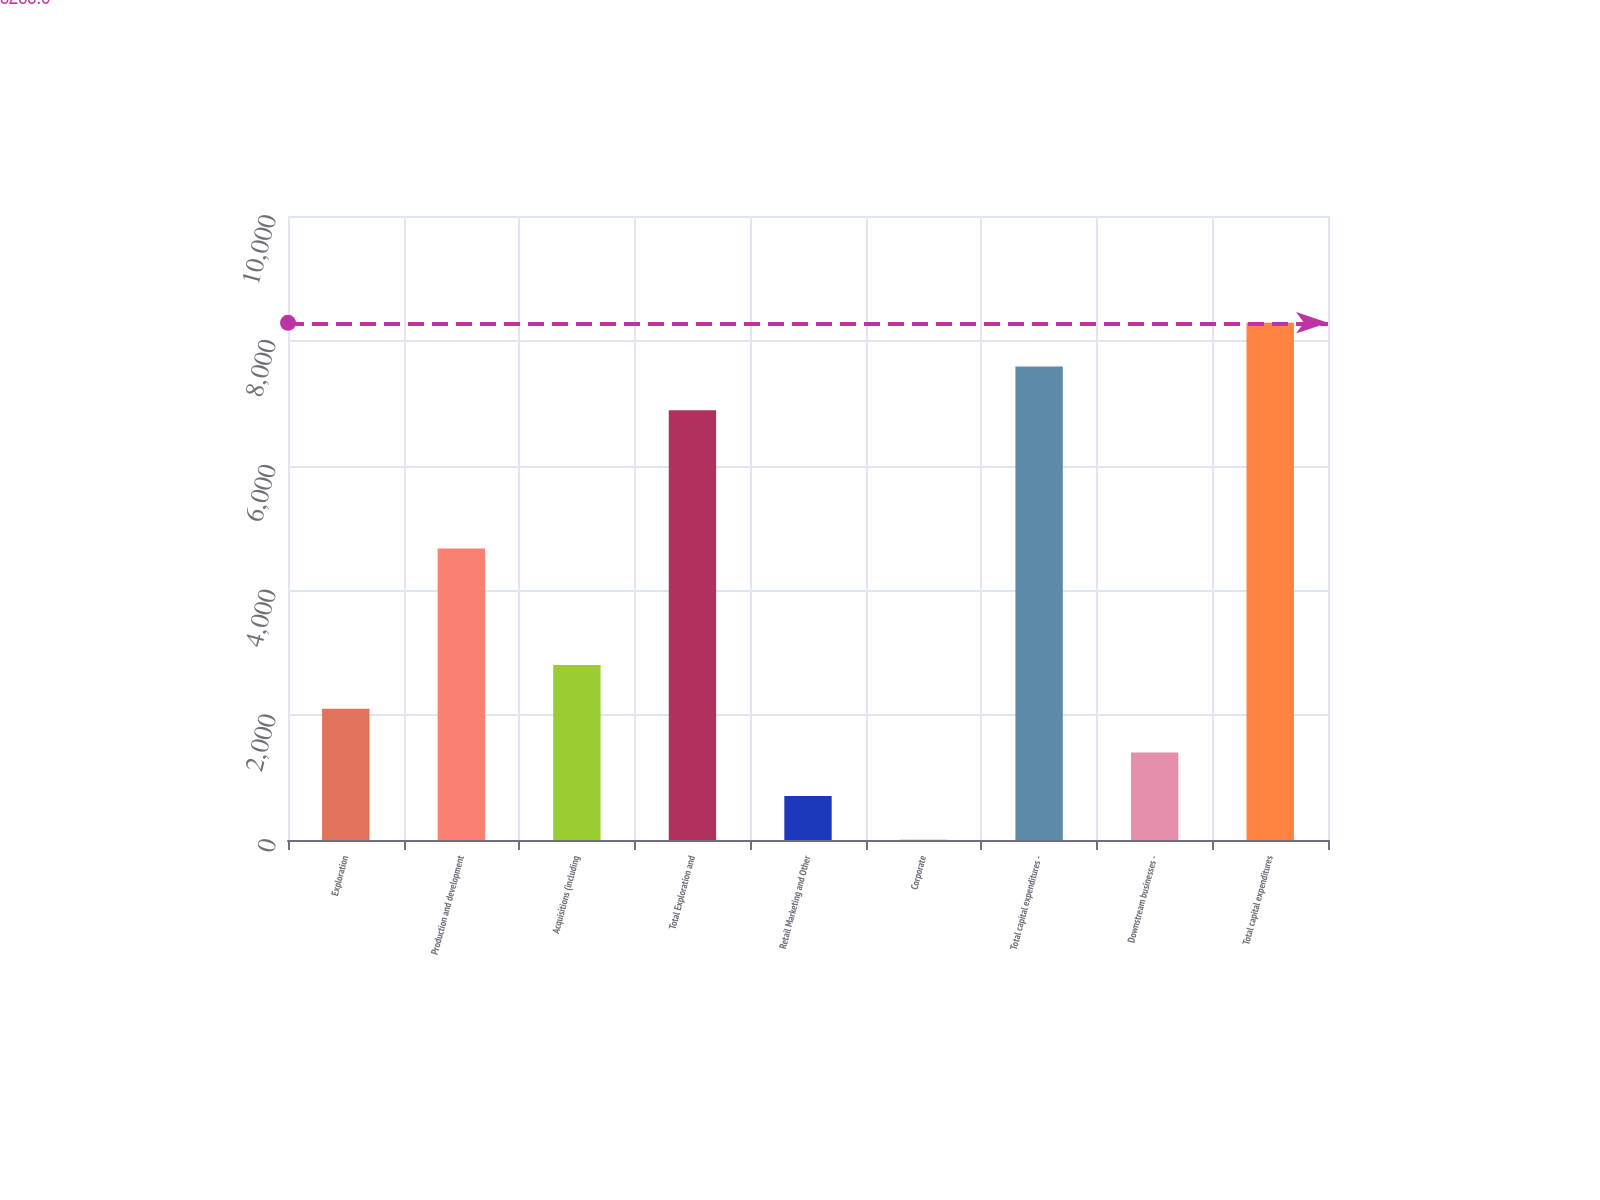Convert chart. <chart><loc_0><loc_0><loc_500><loc_500><bar_chart><fcel>Exploration<fcel>Production and development<fcel>Acquisitions (including<fcel>Total Exploration and<fcel>Retail Marketing and Other<fcel>Corporate<fcel>Total capital expenditures -<fcel>Downstream businesses -<fcel>Total capital expenditures<nl><fcel>2103.9<fcel>4673<fcel>2804.2<fcel>6888<fcel>703.3<fcel>3<fcel>7588.3<fcel>1403.6<fcel>8288.6<nl></chart> 